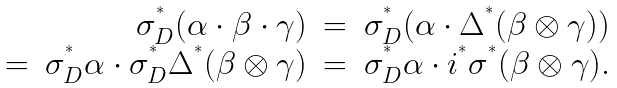Convert formula to latex. <formula><loc_0><loc_0><loc_500><loc_500>\begin{array} { r r c l } & \sigma _ { D } ^ { ^ { * } } ( \alpha \cdot \beta \cdot \gamma ) & = & \sigma _ { D } ^ { ^ { * } } ( \alpha \cdot \Delta ^ { ^ { * } } ( \beta \otimes \gamma ) ) \\ = & \sigma _ { D } ^ { ^ { * } } \alpha \cdot \sigma _ { D } ^ { ^ { * } } \Delta ^ { ^ { * } } ( \beta \otimes \gamma ) & = & \sigma _ { D } ^ { ^ { * } } \alpha \cdot i ^ { ^ { * } } \sigma ^ { ^ { * } } ( \beta \otimes \gamma ) . \end{array}</formula> 